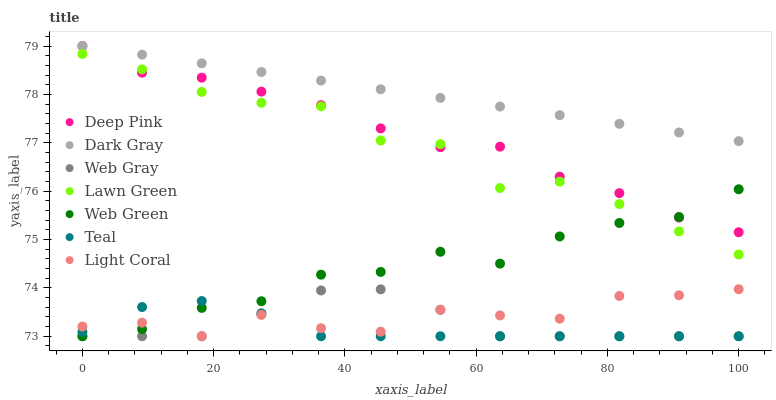Does Teal have the minimum area under the curve?
Answer yes or no. Yes. Does Dark Gray have the maximum area under the curve?
Answer yes or no. Yes. Does Deep Pink have the minimum area under the curve?
Answer yes or no. No. Does Deep Pink have the maximum area under the curve?
Answer yes or no. No. Is Dark Gray the smoothest?
Answer yes or no. Yes. Is Lawn Green the roughest?
Answer yes or no. Yes. Is Deep Pink the smoothest?
Answer yes or no. No. Is Deep Pink the roughest?
Answer yes or no. No. Does Web Green have the lowest value?
Answer yes or no. Yes. Does Deep Pink have the lowest value?
Answer yes or no. No. Does Dark Gray have the highest value?
Answer yes or no. Yes. Does Web Green have the highest value?
Answer yes or no. No. Is Teal less than Deep Pink?
Answer yes or no. Yes. Is Dark Gray greater than Web Green?
Answer yes or no. Yes. Does Web Green intersect Light Coral?
Answer yes or no. Yes. Is Web Green less than Light Coral?
Answer yes or no. No. Is Web Green greater than Light Coral?
Answer yes or no. No. Does Teal intersect Deep Pink?
Answer yes or no. No. 